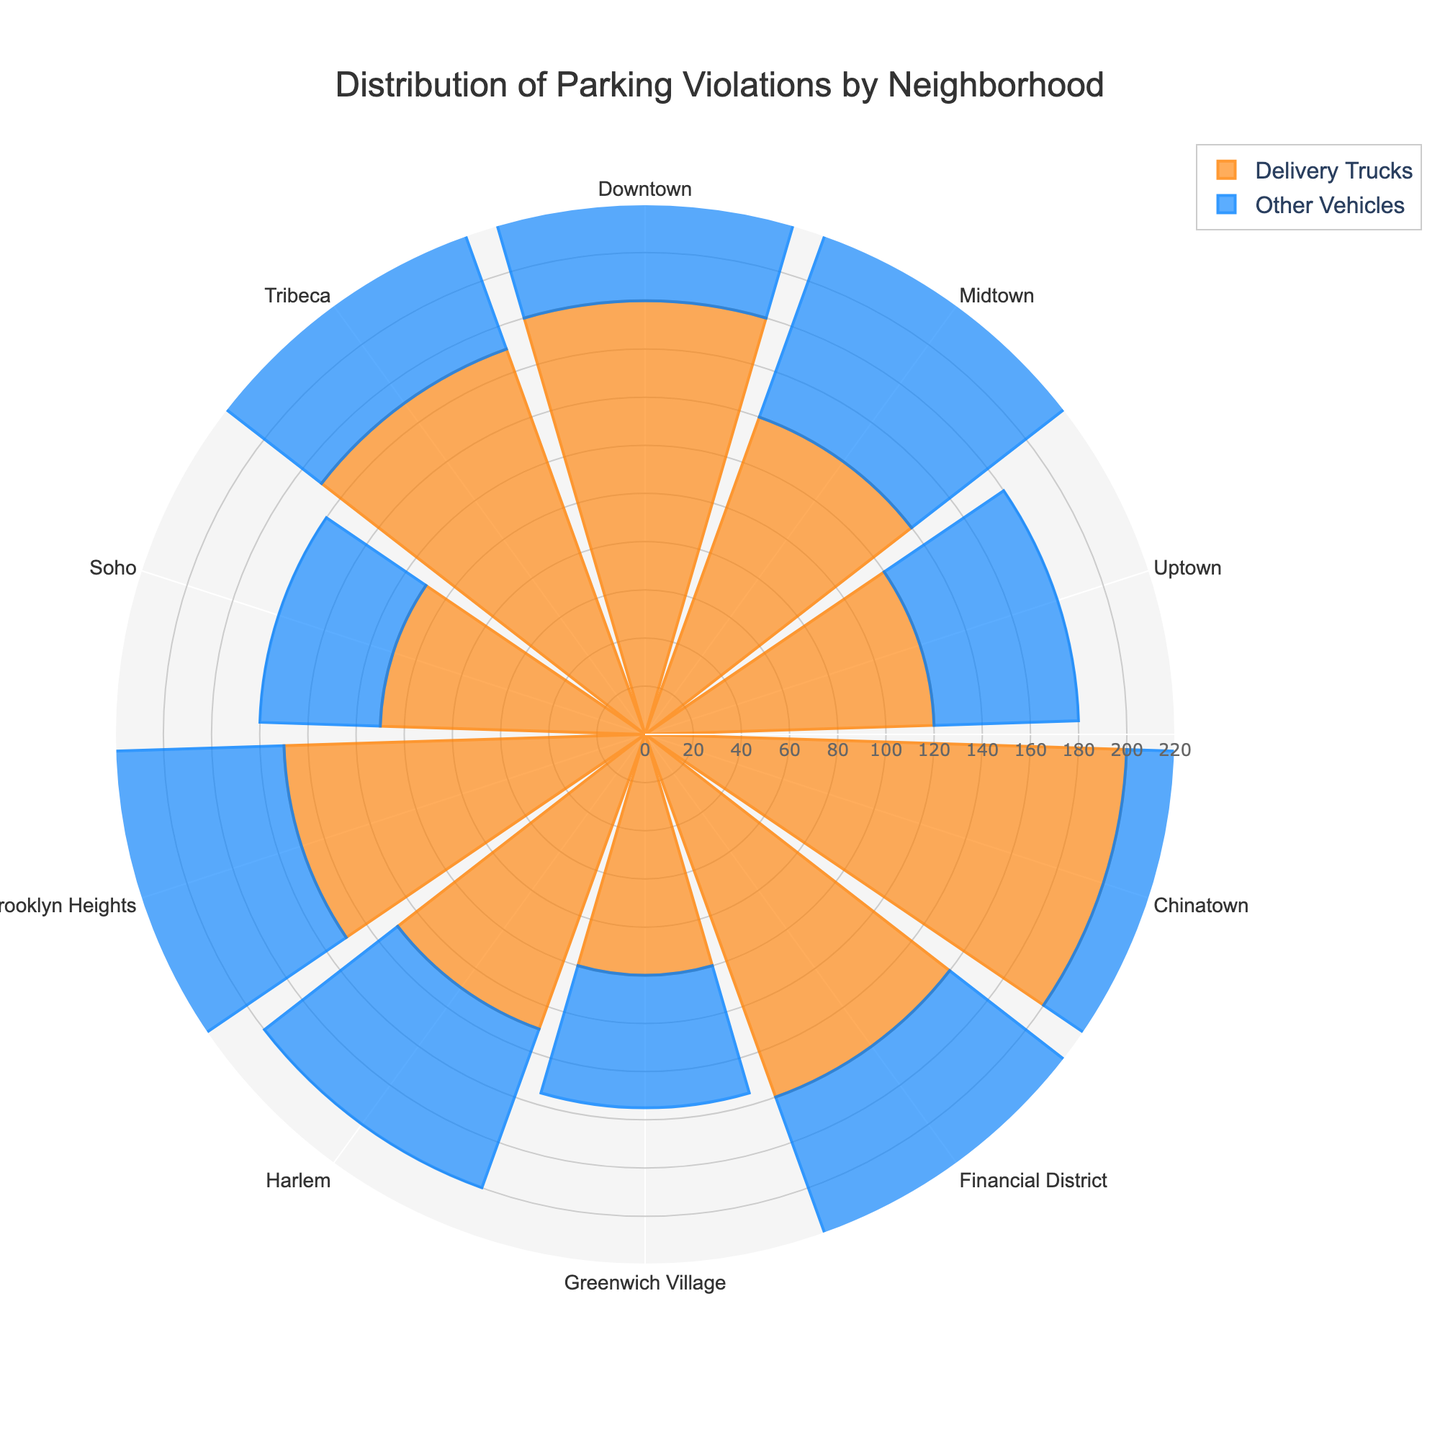What's the title of the polar area chart? The title of the polar area chart is usually found at the top of the figure and is meant to summarize the main message of the chart. In this case, the title is 'Distribution of Parking Violations by Neighborhood'.
Answer: Distribution of Parking Violations by Neighborhood Which neighborhood has the highest number of parking violations for delivery trucks? To find the neighborhood with the highest number of parking violations for delivery trucks, look for the bar representing delivery trucks that extends the most from the center. From the dataset, it is evident that Chinatown has 200 violations, the highest number.
Answer: Chinatown How many neighborhoods have more parking violations for delivery trucks compared to other vehicles? To determine this, compare the length of the bars for delivery trucks and other vehicles in each neighborhood. There are multiple neighborhoods where the bar for delivery trucks extends further than that for other vehicles: Downtown, Midtown, Uptown, Chinatown, Financial District, Harlem, Brooklyn Heights, Soho, and Tribeca. Count them to get the total.
Answer: 9 neighborhoods In which neighborhood do other vehicles have the fewest parking violations? Look for the neighborhood with the smallest bar for other vehicles from the center. According to the dataset, Soho has the fewest parking violations for other vehicles with 50.
Answer: Soho What is the combined total of parking violations issued to delivery trucks in Downtown and Chinatown? Add the number of parking violations for delivery trucks in Downtown (180) and Chinatown (200) to get their combined total.  180 + 200 = 380
Answer: 380 Which neighborhood shows the smallest difference in parking violations between delivery trucks and other vehicles? Calculate the difference in violations for each neighborhood and determine which has the smallest gap. Differences are: Downtown: 180-90=90, Midtown: 140-85=55, Uptown: 120-60=60, etc. The smallest difference is in Soho, where the difference is 110 - 50 = 60.
Answer: Midtown How do parking violations for delivery trucks in Financial District compare to those in Brooklyn Heights? This question requires a direct comparison. The violations in Financial District are 160 while in Brooklyn Heights they are 150. Financial District has slightly more violations.
Answer: Financial District has more Which neighborhoods have parking violations for other vehicles greater than 80? Identify the neighborhoods where the bar for other vehicles extends past the 80 mark. According to the dataset, these neighborhoods are Downtown (90), Chinatown (105), and Brooklyn Heights (95).
Answer: Downtown, Chinatown, Brooklyn Heights What is the average number of parking violations for delivery trucks across all neighborhoods? Add up all the parking violations for delivery trucks across all neighborhoods and divide by the number of neighborhoods. (180 + 140 + 120 + 200 + 160 + 100 + 130 + 150 + 110 + 170) / 10. The total is 1460, thus 1460 / 10 = 146.
Answer: 146 Which neighborhood has the highest total number of parking violations for both delivery trucks and other vehicles combined? Sum up the violations for both delivery trucks and other vehicles for each neighborhood and find the maximum. Chinatown's combined total is the highest: 200 (delivery trucks) + 105 (other vehicles) = 305.
Answer: Chinatown 